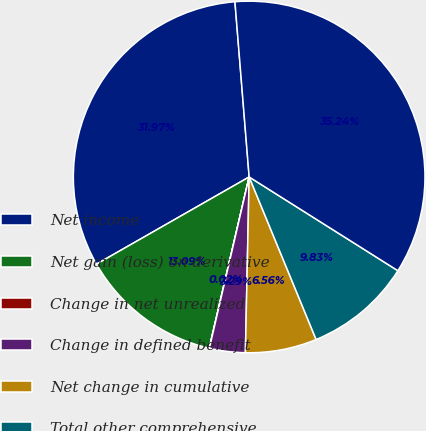Convert chart to OTSL. <chart><loc_0><loc_0><loc_500><loc_500><pie_chart><fcel>Net income<fcel>Net gain (loss) on derivative<fcel>Change in net unrealized<fcel>Change in defined benefit<fcel>Net change in cumulative<fcel>Total other comprehensive<fcel>Total comprehensive income<nl><fcel>31.97%<fcel>13.09%<fcel>0.02%<fcel>3.29%<fcel>6.56%<fcel>9.83%<fcel>35.24%<nl></chart> 